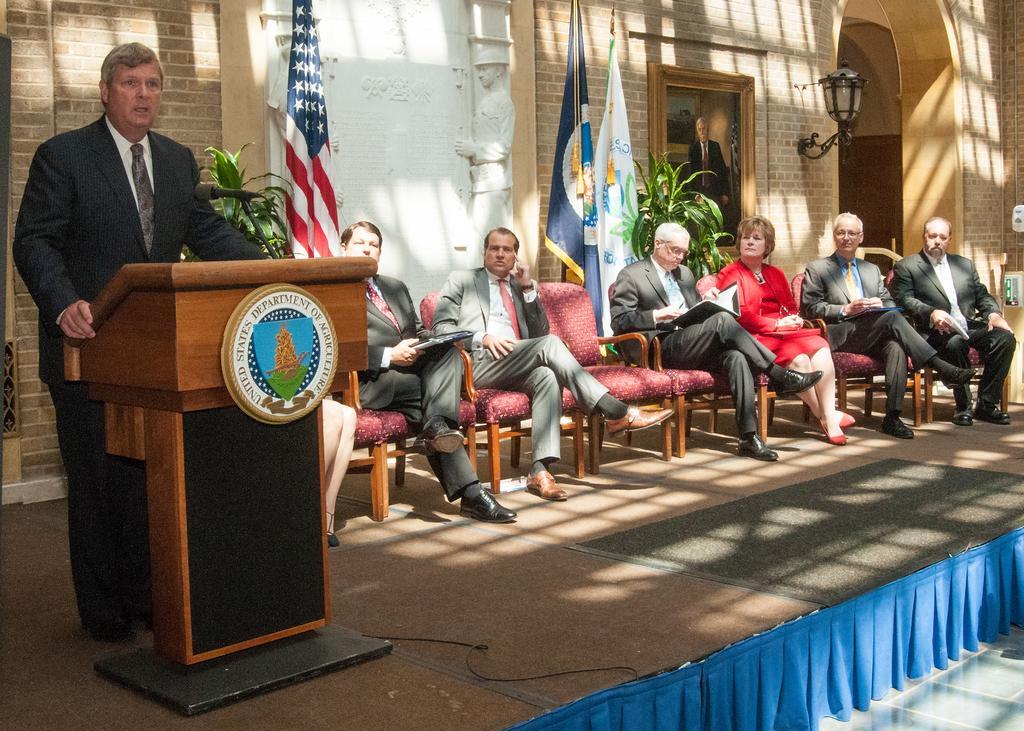How would you summarize this image in a sentence or two? In this picture we can see so many people are sitting in the chairs in front of the building, one person is standing and talking with the help of mike. 